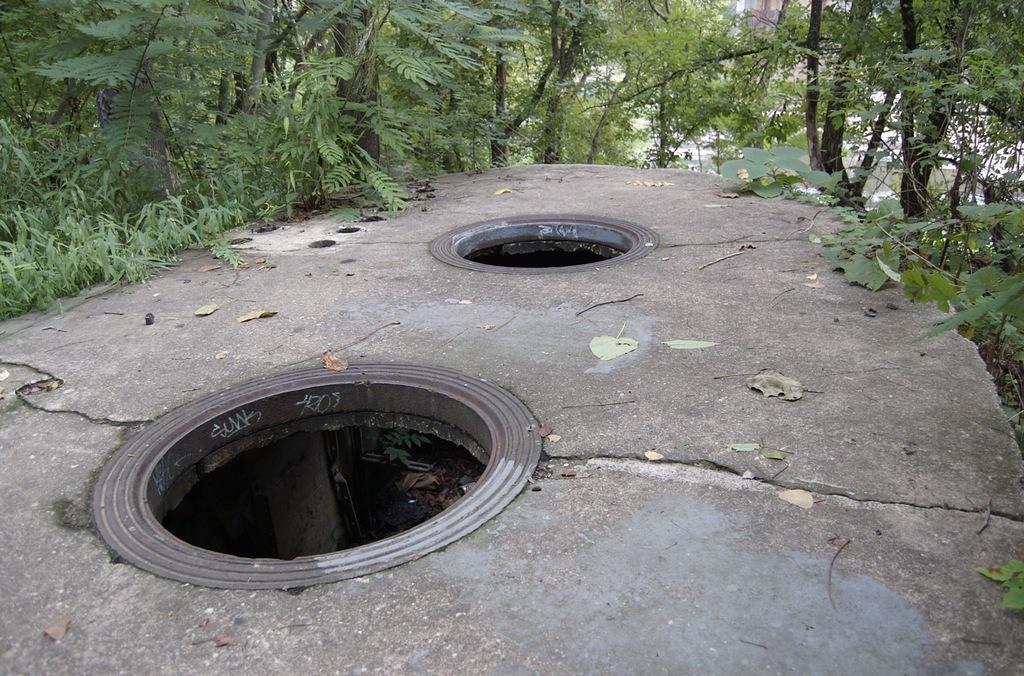Describe this image in one or two sentences. This picture might be taken outside of the city. In this image, in the middle, we can see two holes on the floor. In the background, we can see some trees. 